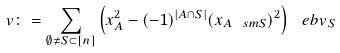Convert formula to latex. <formula><loc_0><loc_0><loc_500><loc_500>v \colon = \sum _ { \emptyset \neq S \subset [ n ] } \left ( x _ { A } ^ { 2 } - ( - 1 ) ^ { | A \cap S | } ( x _ { A \ s m S } ) ^ { 2 } \right ) \ e b v _ { S }</formula> 